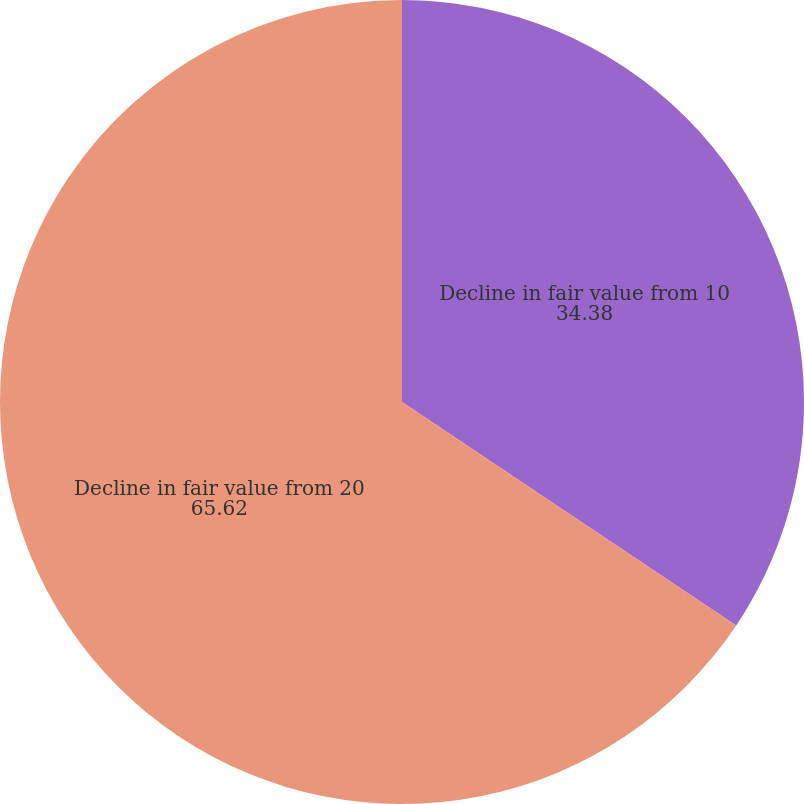Convert chart to OTSL. <chart><loc_0><loc_0><loc_500><loc_500><pie_chart><fcel>Decline in fair value from 10<fcel>Decline in fair value from 20<nl><fcel>34.38%<fcel>65.62%<nl></chart> 